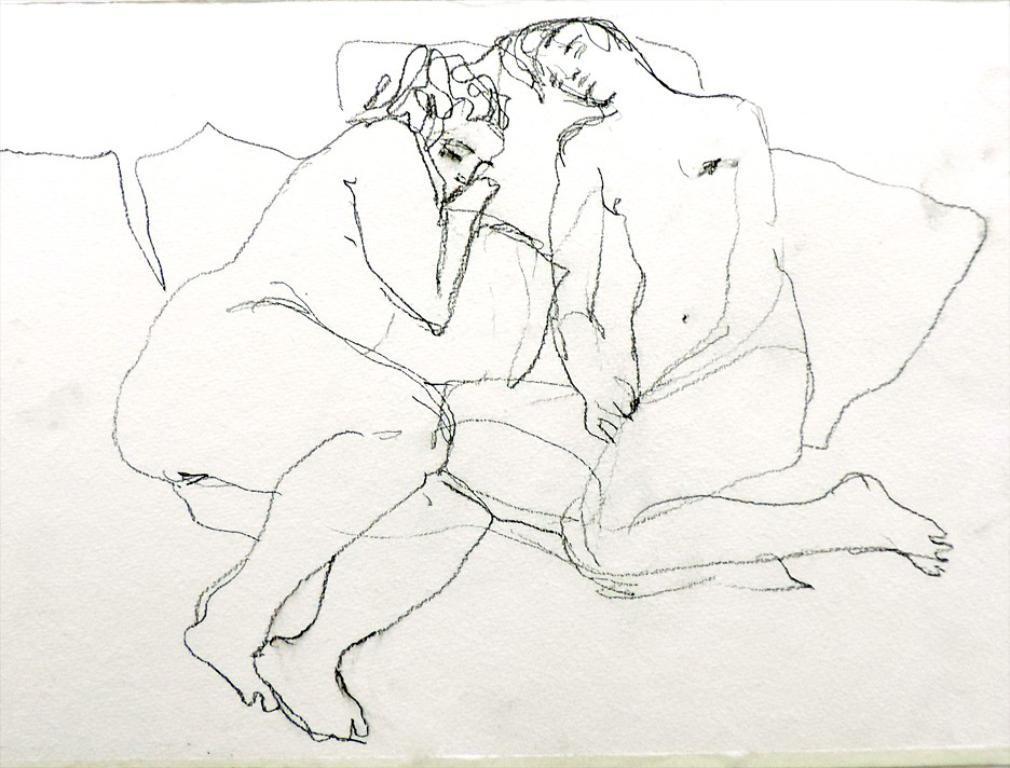Please provide a concise description of this image. There is a drawing image of persons as we can see in the middle of this image 